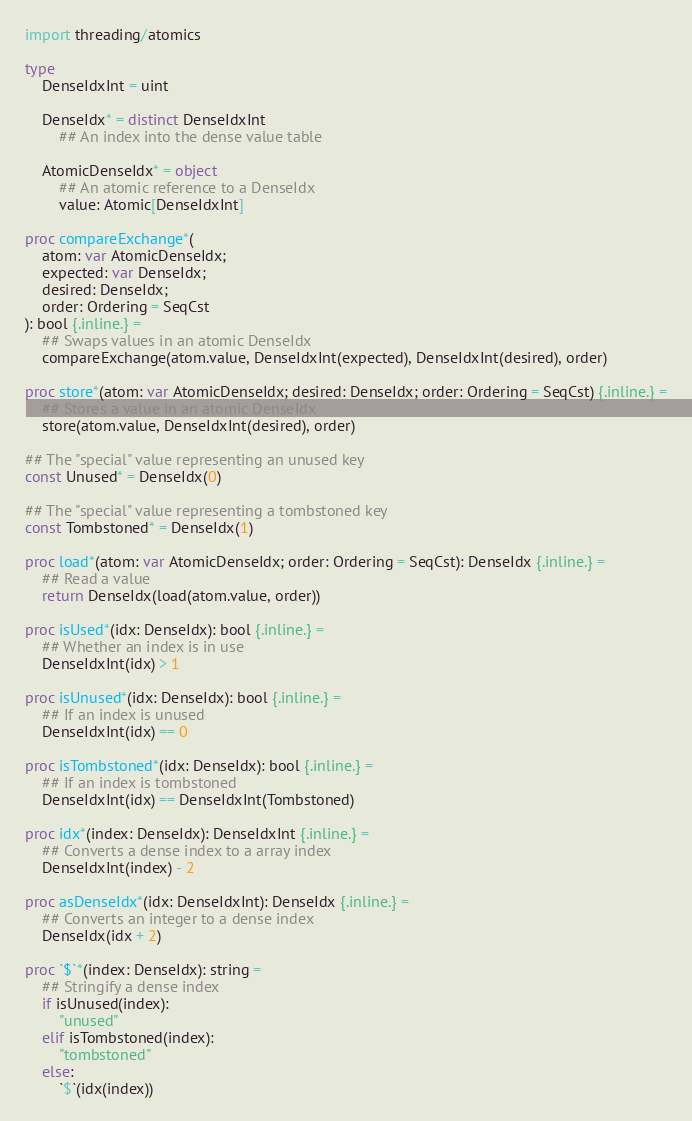Convert code to text. <code><loc_0><loc_0><loc_500><loc_500><_Nim_>import threading/atomics

type
    DenseIdxInt = uint

    DenseIdx* = distinct DenseIdxInt
        ## An index into the dense value table

    AtomicDenseIdx* = object
        ## An atomic reference to a DenseIdx
        value: Atomic[DenseIdxInt]

proc compareExchange*(
    atom: var AtomicDenseIdx;
    expected: var DenseIdx;
    desired: DenseIdx;
    order: Ordering = SeqCst
): bool {.inline.} =
    ## Swaps values in an atomic DenseIdx
    compareExchange(atom.value, DenseIdxInt(expected), DenseIdxInt(desired), order)

proc store*(atom: var AtomicDenseIdx; desired: DenseIdx; order: Ordering = SeqCst) {.inline.} =
    ## Stores a value in an atomic DenseIdx
    store(atom.value, DenseIdxInt(desired), order)

## The "special" value representing an unused key
const Unused* = DenseIdx(0)

## The "special" value representing a tombstoned key
const Tombstoned* = DenseIdx(1)

proc load*(atom: var AtomicDenseIdx; order: Ordering = SeqCst): DenseIdx {.inline.} =
    ## Read a value
    return DenseIdx(load(atom.value, order))

proc isUsed*(idx: DenseIdx): bool {.inline.} =
    ## Whether an index is in use
    DenseIdxInt(idx) > 1

proc isUnused*(idx: DenseIdx): bool {.inline.} =
    ## If an index is unused
    DenseIdxInt(idx) == 0

proc isTombstoned*(idx: DenseIdx): bool {.inline.} =
    ## If an index is tombstoned
    DenseIdxInt(idx) == DenseIdxInt(Tombstoned)

proc idx*(index: DenseIdx): DenseIdxInt {.inline.} =
    ## Converts a dense index to a array index
    DenseIdxInt(index) - 2

proc asDenseIdx*(idx: DenseIdxInt): DenseIdx {.inline.} =
    ## Converts an integer to a dense index
    DenseIdx(idx + 2)

proc `$`*(index: DenseIdx): string =
    ## Stringify a dense index
    if isUnused(index):
        "unused"
    elif isTombstoned(index):
        "tombstoned"
    else:
        `$`(idx(index))
</code> 